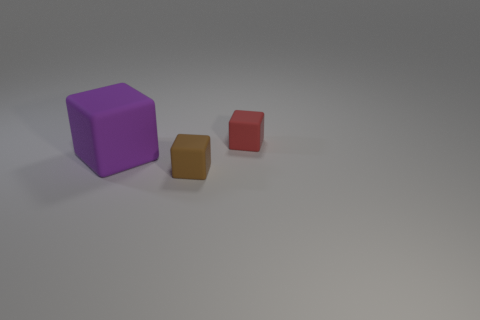What material is the small red thing that is the same shape as the big purple thing?
Offer a very short reply. Rubber. What is the size of the purple matte thing in front of the tiny thing on the right side of the tiny brown thing?
Make the answer very short. Large. Is the number of small rubber things that are in front of the red rubber block greater than the number of big brown matte cubes?
Your response must be concise. Yes. Do the matte block in front of the purple block and the large purple thing have the same size?
Your answer should be very brief. No. There is a thing that is both behind the tiny brown cube and on the right side of the large purple object; what is its color?
Make the answer very short. Red. What is the shape of the brown rubber thing that is the same size as the red cube?
Make the answer very short. Cube. Are there an equal number of red rubber cubes in front of the brown rubber block and small cyan matte balls?
Provide a short and direct response. Yes. What size is the matte block that is both behind the small brown matte block and right of the large purple block?
Keep it short and to the point. Small. What is the color of the big thing that is made of the same material as the brown cube?
Give a very brief answer. Purple. How many small brown objects have the same material as the large thing?
Give a very brief answer. 1. 